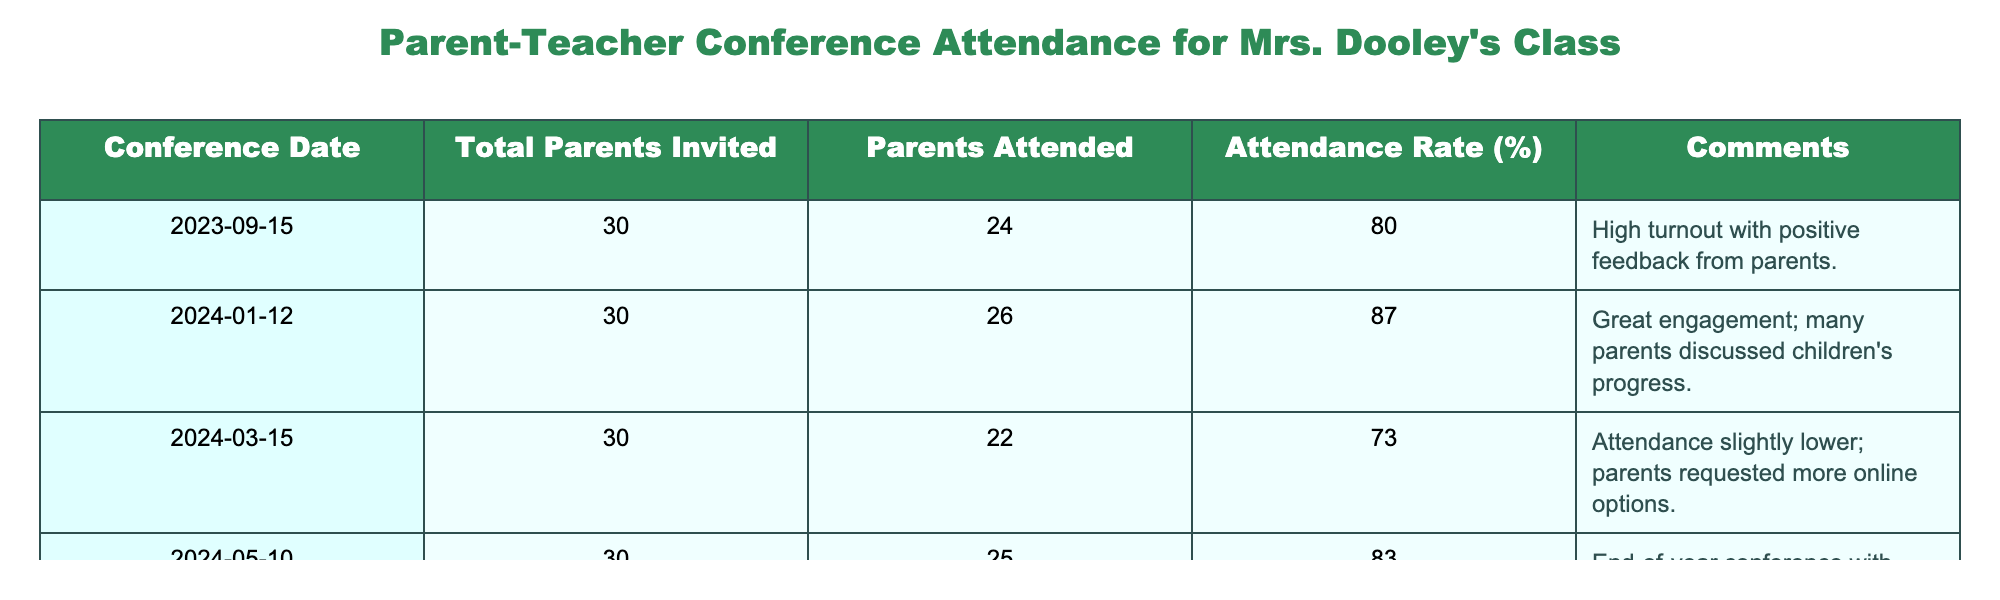What was the attendance rate for the conference on March 15, 2024? The attendance rate for that specific date is explicitly listed in the table under the "Attendance Rate (%)" column. For March 15, 2024, it states "73".
Answer: 73% How many parents attended the conference on January 12, 2024? The number of parents who attended can be found in the table under the "Parents Attended" column for that specific conference date. For January 12, 2024, it is "26".
Answer: 26 What is the average attendance rate across all conferences? To find the average attendance rate, sum all the attendance rates: (80 + 87 + 73 + 83) = 323. Then, divide that sum by the number of conferences (4): 323/4 = 80.75.
Answer: 80.75% Did more parents attend the conference in January than in September? By comparing the number of parents who attended in those two months, 26 (January) is greater than 24 (September). Therefore, more parents attended in January.
Answer: Yes Which conference had the highest attendance rate? The highest attendance rate can be found by examining the "Attendance Rate (%)" column. From the data, the highest rate is "87" for January 12, 2024.
Answer: January 12, 2024 What is the total number of parents invited to all conferences combined? To find this total, add the number of parents invited for each conference: (30 + 30 + 30 + 30) = 120. This gives the total number of parents invited to all conferences combined.
Answer: 120 Was there a conference with an attendance rate below 75%? Checking the attendance rates listed in the table, the conference on March 15, 2024, had an attendance rate of "73", which is below 75%.
Answer: Yes What was the difference in attendance between the September and May conferences? The attendance for September is 24 and for May is 25. The difference is 25 - 24 = 1; hence, one more parent attended in May than in September.
Answer: 1 